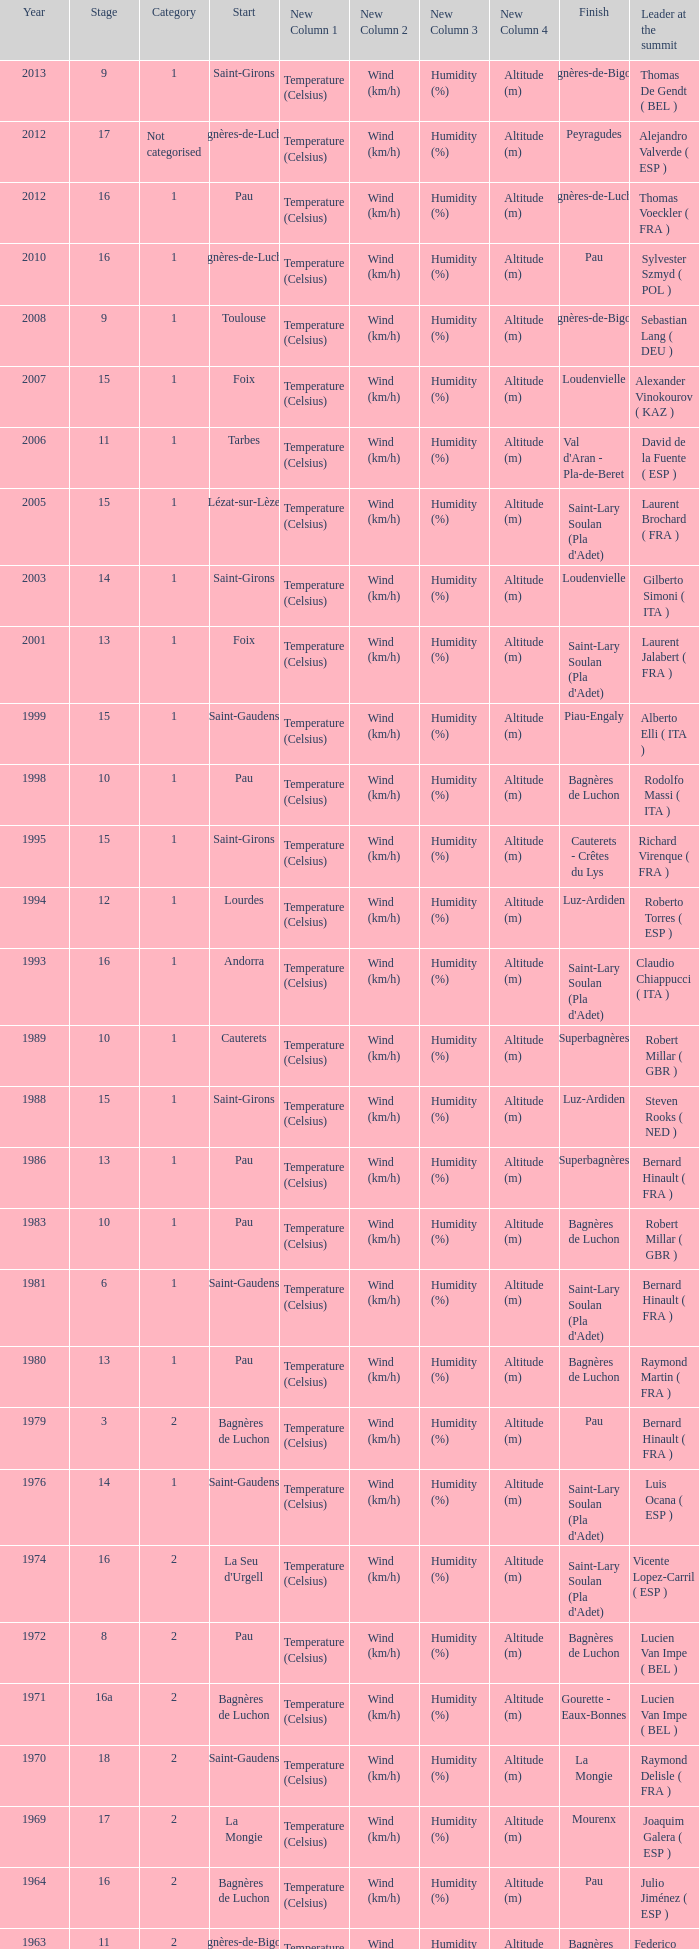What stage has a start of saint-girons in 1988? 15.0. Could you parse the entire table? {'header': ['Year', 'Stage', 'Category', 'Start', 'New Column 1', 'New Column 2', 'New Column 3', 'New Column 4', 'Finish', 'Leader at the summit'], 'rows': [['2013', '9', '1', 'Saint-Girons', 'Temperature (Celsius)', 'Wind (km/h)', 'Humidity (%)', 'Altitude (m)', 'Bagnères-de-Bigorre', 'Thomas De Gendt ( BEL )'], ['2012', '17', 'Not categorised', 'Bagnères-de-Luchon', 'Temperature (Celsius)', 'Wind (km/h)', 'Humidity (%)', 'Altitude (m)', 'Peyragudes', 'Alejandro Valverde ( ESP )'], ['2012', '16', '1', 'Pau', 'Temperature (Celsius)', 'Wind (km/h)', 'Humidity (%)', 'Altitude (m)', 'Bagnères-de-Luchon', 'Thomas Voeckler ( FRA )'], ['2010', '16', '1', 'Bagnères-de-Luchon', 'Temperature (Celsius)', 'Wind (km/h)', 'Humidity (%)', 'Altitude (m)', 'Pau', 'Sylvester Szmyd ( POL )'], ['2008', '9', '1', 'Toulouse', 'Temperature (Celsius)', 'Wind (km/h)', 'Humidity (%)', 'Altitude (m)', 'Bagnères-de-Bigorre', 'Sebastian Lang ( DEU )'], ['2007', '15', '1', 'Foix', 'Temperature (Celsius)', 'Wind (km/h)', 'Humidity (%)', 'Altitude (m)', 'Loudenvielle', 'Alexander Vinokourov ( KAZ )'], ['2006', '11', '1', 'Tarbes', 'Temperature (Celsius)', 'Wind (km/h)', 'Humidity (%)', 'Altitude (m)', "Val d'Aran - Pla-de-Beret", 'David de la Fuente ( ESP )'], ['2005', '15', '1', 'Lézat-sur-Lèze', 'Temperature (Celsius)', 'Wind (km/h)', 'Humidity (%)', 'Altitude (m)', "Saint-Lary Soulan (Pla d'Adet)", 'Laurent Brochard ( FRA )'], ['2003', '14', '1', 'Saint-Girons', 'Temperature (Celsius)', 'Wind (km/h)', 'Humidity (%)', 'Altitude (m)', 'Loudenvielle', 'Gilberto Simoni ( ITA )'], ['2001', '13', '1', 'Foix', 'Temperature (Celsius)', 'Wind (km/h)', 'Humidity (%)', 'Altitude (m)', "Saint-Lary Soulan (Pla d'Adet)", 'Laurent Jalabert ( FRA )'], ['1999', '15', '1', 'Saint-Gaudens', 'Temperature (Celsius)', 'Wind (km/h)', 'Humidity (%)', 'Altitude (m)', 'Piau-Engaly', 'Alberto Elli ( ITA )'], ['1998', '10', '1', 'Pau', 'Temperature (Celsius)', 'Wind (km/h)', 'Humidity (%)', 'Altitude (m)', 'Bagnères de Luchon', 'Rodolfo Massi ( ITA )'], ['1995', '15', '1', 'Saint-Girons', 'Temperature (Celsius)', 'Wind (km/h)', 'Humidity (%)', 'Altitude (m)', 'Cauterets - Crêtes du Lys', 'Richard Virenque ( FRA )'], ['1994', '12', '1', 'Lourdes', 'Temperature (Celsius)', 'Wind (km/h)', 'Humidity (%)', 'Altitude (m)', 'Luz-Ardiden', 'Roberto Torres ( ESP )'], ['1993', '16', '1', 'Andorra', 'Temperature (Celsius)', 'Wind (km/h)', 'Humidity (%)', 'Altitude (m)', "Saint-Lary Soulan (Pla d'Adet)", 'Claudio Chiappucci ( ITA )'], ['1989', '10', '1', 'Cauterets', 'Temperature (Celsius)', 'Wind (km/h)', 'Humidity (%)', 'Altitude (m)', 'Superbagnères', 'Robert Millar ( GBR )'], ['1988', '15', '1', 'Saint-Girons', 'Temperature (Celsius)', 'Wind (km/h)', 'Humidity (%)', 'Altitude (m)', 'Luz-Ardiden', 'Steven Rooks ( NED )'], ['1986', '13', '1', 'Pau', 'Temperature (Celsius)', 'Wind (km/h)', 'Humidity (%)', 'Altitude (m)', 'Superbagnères', 'Bernard Hinault ( FRA )'], ['1983', '10', '1', 'Pau', 'Temperature (Celsius)', 'Wind (km/h)', 'Humidity (%)', 'Altitude (m)', 'Bagnères de Luchon', 'Robert Millar ( GBR )'], ['1981', '6', '1', 'Saint-Gaudens', 'Temperature (Celsius)', 'Wind (km/h)', 'Humidity (%)', 'Altitude (m)', "Saint-Lary Soulan (Pla d'Adet)", 'Bernard Hinault ( FRA )'], ['1980', '13', '1', 'Pau', 'Temperature (Celsius)', 'Wind (km/h)', 'Humidity (%)', 'Altitude (m)', 'Bagnères de Luchon', 'Raymond Martin ( FRA )'], ['1979', '3', '2', 'Bagnères de Luchon', 'Temperature (Celsius)', 'Wind (km/h)', 'Humidity (%)', 'Altitude (m)', 'Pau', 'Bernard Hinault ( FRA )'], ['1976', '14', '1', 'Saint-Gaudens', 'Temperature (Celsius)', 'Wind (km/h)', 'Humidity (%)', 'Altitude (m)', "Saint-Lary Soulan (Pla d'Adet)", 'Luis Ocana ( ESP )'], ['1974', '16', '2', "La Seu d'Urgell", 'Temperature (Celsius)', 'Wind (km/h)', 'Humidity (%)', 'Altitude (m)', "Saint-Lary Soulan (Pla d'Adet)", 'Vicente Lopez-Carril ( ESP )'], ['1972', '8', '2', 'Pau', 'Temperature (Celsius)', 'Wind (km/h)', 'Humidity (%)', 'Altitude (m)', 'Bagnères de Luchon', 'Lucien Van Impe ( BEL )'], ['1971', '16a', '2', 'Bagnères de Luchon', 'Temperature (Celsius)', 'Wind (km/h)', 'Humidity (%)', 'Altitude (m)', 'Gourette - Eaux-Bonnes', 'Lucien Van Impe ( BEL )'], ['1970', '18', '2', 'Saint-Gaudens', 'Temperature (Celsius)', 'Wind (km/h)', 'Humidity (%)', 'Altitude (m)', 'La Mongie', 'Raymond Delisle ( FRA )'], ['1969', '17', '2', 'La Mongie', 'Temperature (Celsius)', 'Wind (km/h)', 'Humidity (%)', 'Altitude (m)', 'Mourenx', 'Joaquim Galera ( ESP )'], ['1964', '16', '2', 'Bagnères de Luchon', 'Temperature (Celsius)', 'Wind (km/h)', 'Humidity (%)', 'Altitude (m)', 'Pau', 'Julio Jiménez ( ESP )'], ['1963', '11', '2', 'Bagnères-de-Bigorre', 'Temperature (Celsius)', 'Wind (km/h)', 'Humidity (%)', 'Altitude (m)', 'Bagnères de Luchon', 'Federico Bahamontes ( ESP )'], ['1962', '12', '2', 'Pau', 'Temperature (Celsius)', 'Wind (km/h)', 'Humidity (%)', 'Altitude (m)', 'Saint-Gaudens', 'Federico Bahamontes ( ESP )'], ['1961', '17', '2', 'Bagnères de Luchon', 'Temperature (Celsius)', 'Wind (km/h)', 'Humidity (%)', 'Altitude (m)', 'Pau', 'Imerio Massignan ( ITA )'], ['1960', '11', '1', 'Pau', 'Temperature (Celsius)', 'Wind (km/h)', 'Humidity (%)', 'Altitude (m)', 'Bagnères de Luchon', 'Kurt Gimmi ( SUI )'], ['1959', '11', '1', 'Bagnères-de-Bigorre', 'Temperature (Celsius)', 'Wind (km/h)', 'Humidity (%)', 'Altitude (m)', 'Saint-Gaudens', 'Valentin Huot ( FRA )'], ['1958', '14', '1', 'Pau', 'Temperature (Celsius)', 'Wind (km/h)', 'Humidity (%)', 'Altitude (m)', 'Bagnères de Luchon', 'Federico Bahamontes ( ESP )'], ['1956', '12', 'Not categorised', 'Pau', 'Temperature (Celsius)', 'Wind (km/h)', 'Humidity (%)', 'Altitude (m)', 'Bagnères de Luchon', 'Jean-Pierre Schmitz ( LUX )'], ['1955', '17', '2', 'Toulouse', 'Temperature (Celsius)', 'Wind (km/h)', 'Humidity (%)', 'Altitude (m)', 'Saint-Gaudens', 'Charly Gaul ( LUX )'], ['1954', '12', '2', 'Pau', 'Temperature (Celsius)', 'Wind (km/h)', 'Humidity (%)', 'Altitude (m)', 'Bagnères de Luchon', 'Federico Bahamontes ( ESP )'], ['1953', '11', '2', 'Cauterets', 'Temperature (Celsius)', 'Wind (km/h)', 'Humidity (%)', 'Altitude (m)', 'Bagnères de Luchon', 'Jean Robic ( FRA )'], ['1952', '17', '2', 'Toulouse', 'Temperature (Celsius)', 'Wind (km/h)', 'Humidity (%)', 'Altitude (m)', 'Bagnères-de-Bigorre', 'Antonio Gelabert ( ESP )'], ['1951', '14', '2', 'Tarbes', 'Temperature (Celsius)', 'Wind (km/h)', 'Humidity (%)', 'Altitude (m)', 'Bagnères de Luchon', 'Fausto Coppi ( ITA )'], ['1949', '11', '2', 'Pau', 'Temperature (Celsius)', 'Wind (km/h)', 'Humidity (%)', 'Altitude (m)', 'Bagnères de Luchon', 'Jean Robic ( FRA )'], ['1948', '8', '2', 'Lourdes', 'Temperature (Celsius)', 'Wind (km/h)', 'Humidity (%)', 'Altitude (m)', 'Toulouse', 'Jean Robic ( FRA )'], ['1947', '15', '1', 'Bagnères de Luchon', 'Temperature (Celsius)', 'Wind (km/h)', 'Humidity (%)', 'Altitude (m)', 'Pau', 'Jean Robic ( FRA )']]} 